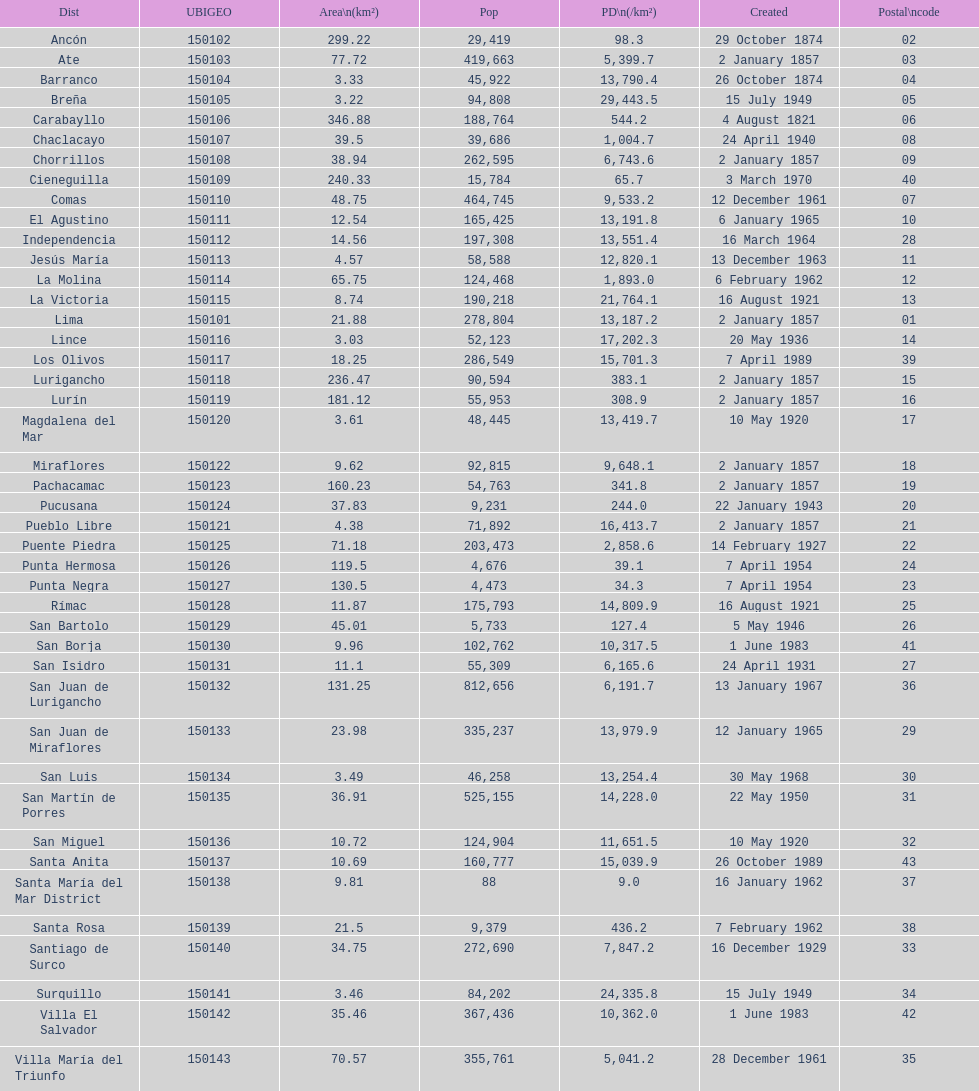Which district in this city has the greatest population? San Juan de Lurigancho. 